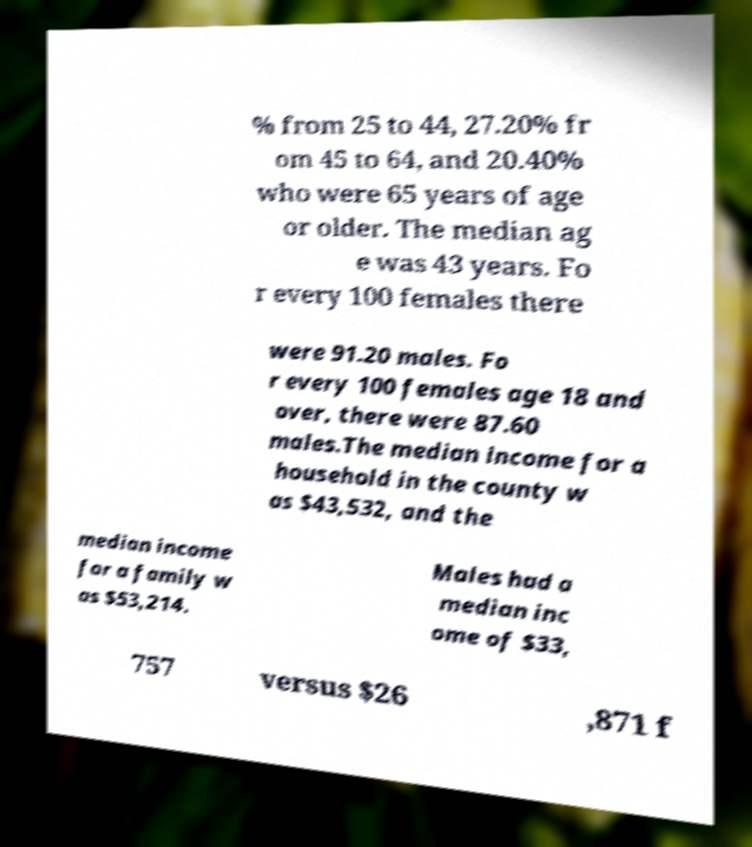For documentation purposes, I need the text within this image transcribed. Could you provide that? % from 25 to 44, 27.20% fr om 45 to 64, and 20.40% who were 65 years of age or older. The median ag e was 43 years. Fo r every 100 females there were 91.20 males. Fo r every 100 females age 18 and over, there were 87.60 males.The median income for a household in the county w as $43,532, and the median income for a family w as $53,214. Males had a median inc ome of $33, 757 versus $26 ,871 f 